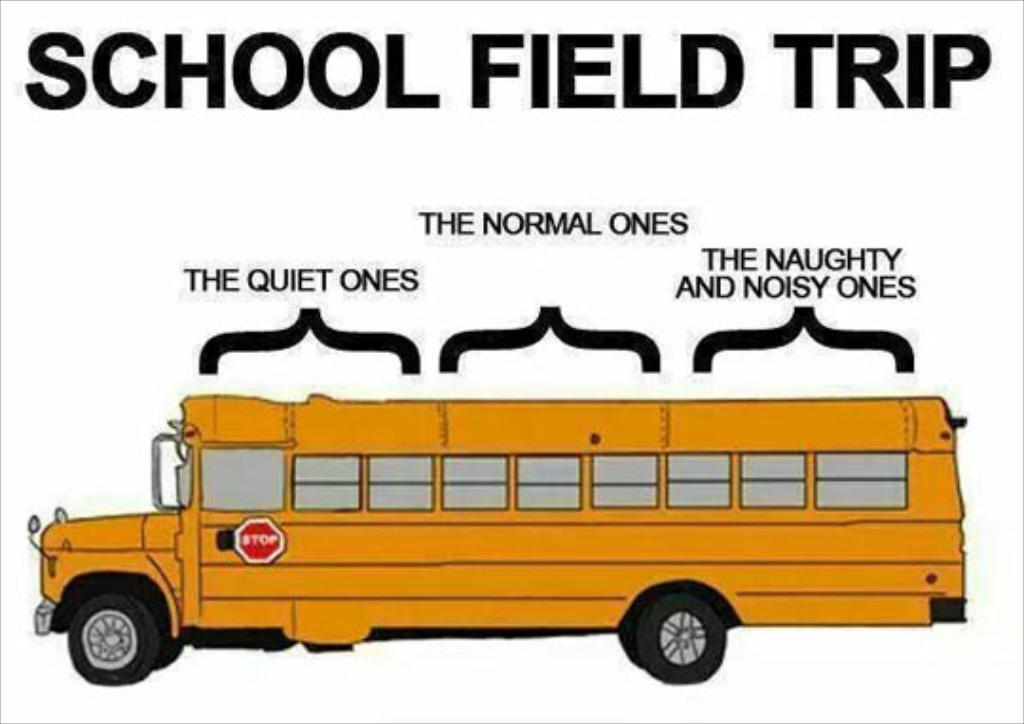What is the main object in the image? There is a poster in the image. What else can be seen in the image besides the poster? There is a vehicle with a sign board in the image. Can you read any text in the image? Yes, there is text visible in the image. How many bottles of water are visible in the image? There are no bottles of water present in the image. What type of teeth can be seen in the image? There are no teeth visible in the image. 